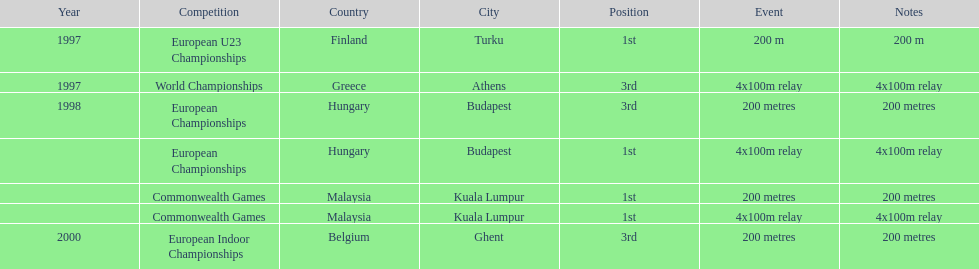In what year did england get the top achievment in the 200 meter? 1997. 